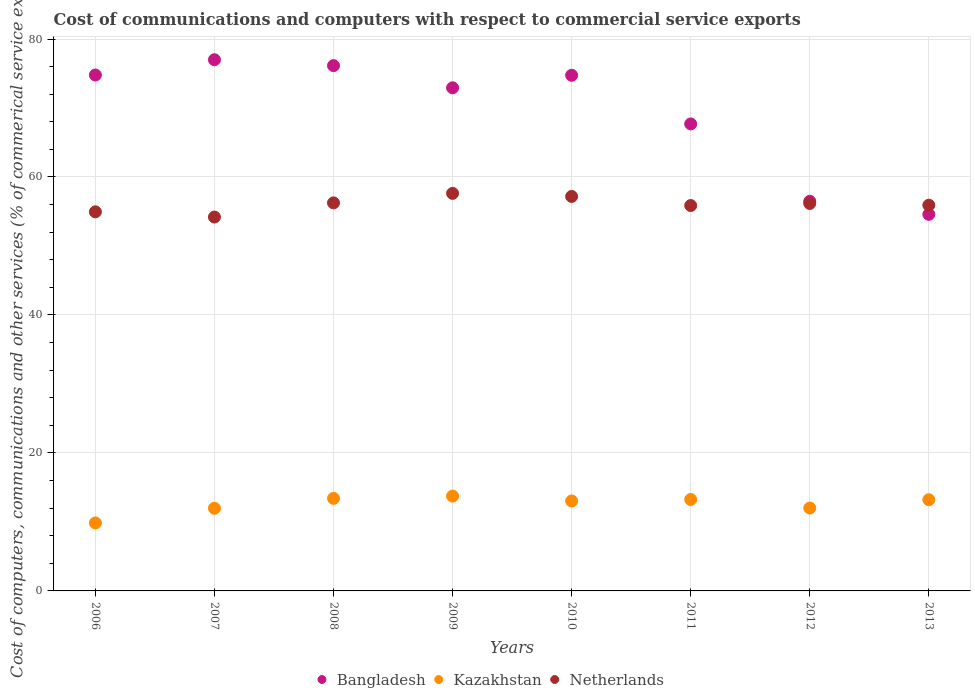Is the number of dotlines equal to the number of legend labels?
Your response must be concise. Yes. What is the cost of communications and computers in Kazakhstan in 2011?
Your answer should be very brief. 13.26. Across all years, what is the maximum cost of communications and computers in Kazakhstan?
Make the answer very short. 13.75. Across all years, what is the minimum cost of communications and computers in Bangladesh?
Offer a terse response. 54.58. In which year was the cost of communications and computers in Kazakhstan minimum?
Your answer should be compact. 2006. What is the total cost of communications and computers in Bangladesh in the graph?
Your answer should be compact. 554.35. What is the difference between the cost of communications and computers in Kazakhstan in 2012 and that in 2013?
Your response must be concise. -1.2. What is the difference between the cost of communications and computers in Netherlands in 2013 and the cost of communications and computers in Bangladesh in 2010?
Give a very brief answer. -18.83. What is the average cost of communications and computers in Bangladesh per year?
Keep it short and to the point. 69.29. In the year 2012, what is the difference between the cost of communications and computers in Bangladesh and cost of communications and computers in Kazakhstan?
Give a very brief answer. 44.46. In how many years, is the cost of communications and computers in Netherlands greater than 16 %?
Your answer should be very brief. 8. What is the ratio of the cost of communications and computers in Bangladesh in 2006 to that in 2007?
Your answer should be very brief. 0.97. Is the difference between the cost of communications and computers in Bangladesh in 2006 and 2007 greater than the difference between the cost of communications and computers in Kazakhstan in 2006 and 2007?
Offer a terse response. No. What is the difference between the highest and the second highest cost of communications and computers in Netherlands?
Ensure brevity in your answer.  0.44. What is the difference between the highest and the lowest cost of communications and computers in Netherlands?
Provide a short and direct response. 3.43. Is the cost of communications and computers in Kazakhstan strictly less than the cost of communications and computers in Bangladesh over the years?
Give a very brief answer. Yes. How many years are there in the graph?
Your answer should be compact. 8. Are the values on the major ticks of Y-axis written in scientific E-notation?
Ensure brevity in your answer.  No. How many legend labels are there?
Make the answer very short. 3. What is the title of the graph?
Your answer should be compact. Cost of communications and computers with respect to commercial service exports. Does "Brazil" appear as one of the legend labels in the graph?
Make the answer very short. No. What is the label or title of the Y-axis?
Your answer should be very brief. Cost of computers, communications and other services (% of commerical service exports). What is the Cost of computers, communications and other services (% of commerical service exports) in Bangladesh in 2006?
Keep it short and to the point. 74.78. What is the Cost of computers, communications and other services (% of commerical service exports) in Kazakhstan in 2006?
Your answer should be compact. 9.85. What is the Cost of computers, communications and other services (% of commerical service exports) in Netherlands in 2006?
Keep it short and to the point. 54.95. What is the Cost of computers, communications and other services (% of commerical service exports) of Bangladesh in 2007?
Provide a short and direct response. 77. What is the Cost of computers, communications and other services (% of commerical service exports) of Kazakhstan in 2007?
Provide a succinct answer. 11.98. What is the Cost of computers, communications and other services (% of commerical service exports) in Netherlands in 2007?
Make the answer very short. 54.19. What is the Cost of computers, communications and other services (% of commerical service exports) in Bangladesh in 2008?
Keep it short and to the point. 76.14. What is the Cost of computers, communications and other services (% of commerical service exports) of Kazakhstan in 2008?
Offer a very short reply. 13.42. What is the Cost of computers, communications and other services (% of commerical service exports) in Netherlands in 2008?
Your answer should be compact. 56.25. What is the Cost of computers, communications and other services (% of commerical service exports) of Bangladesh in 2009?
Give a very brief answer. 72.93. What is the Cost of computers, communications and other services (% of commerical service exports) of Kazakhstan in 2009?
Make the answer very short. 13.75. What is the Cost of computers, communications and other services (% of commerical service exports) in Netherlands in 2009?
Give a very brief answer. 57.63. What is the Cost of computers, communications and other services (% of commerical service exports) of Bangladesh in 2010?
Ensure brevity in your answer.  74.75. What is the Cost of computers, communications and other services (% of commerical service exports) in Kazakhstan in 2010?
Offer a very short reply. 13.04. What is the Cost of computers, communications and other services (% of commerical service exports) of Netherlands in 2010?
Provide a succinct answer. 57.18. What is the Cost of computers, communications and other services (% of commerical service exports) of Bangladesh in 2011?
Your answer should be compact. 67.69. What is the Cost of computers, communications and other services (% of commerical service exports) of Kazakhstan in 2011?
Provide a succinct answer. 13.26. What is the Cost of computers, communications and other services (% of commerical service exports) of Netherlands in 2011?
Your answer should be compact. 55.86. What is the Cost of computers, communications and other services (% of commerical service exports) in Bangladesh in 2012?
Provide a short and direct response. 56.48. What is the Cost of computers, communications and other services (% of commerical service exports) in Kazakhstan in 2012?
Your answer should be very brief. 12.02. What is the Cost of computers, communications and other services (% of commerical service exports) in Netherlands in 2012?
Give a very brief answer. 56.16. What is the Cost of computers, communications and other services (% of commerical service exports) of Bangladesh in 2013?
Your answer should be compact. 54.58. What is the Cost of computers, communications and other services (% of commerical service exports) of Kazakhstan in 2013?
Your response must be concise. 13.22. What is the Cost of computers, communications and other services (% of commerical service exports) in Netherlands in 2013?
Your response must be concise. 55.91. Across all years, what is the maximum Cost of computers, communications and other services (% of commerical service exports) of Bangladesh?
Give a very brief answer. 77. Across all years, what is the maximum Cost of computers, communications and other services (% of commerical service exports) in Kazakhstan?
Ensure brevity in your answer.  13.75. Across all years, what is the maximum Cost of computers, communications and other services (% of commerical service exports) of Netherlands?
Offer a very short reply. 57.63. Across all years, what is the minimum Cost of computers, communications and other services (% of commerical service exports) in Bangladesh?
Provide a short and direct response. 54.58. Across all years, what is the minimum Cost of computers, communications and other services (% of commerical service exports) in Kazakhstan?
Your answer should be compact. 9.85. Across all years, what is the minimum Cost of computers, communications and other services (% of commerical service exports) of Netherlands?
Offer a terse response. 54.19. What is the total Cost of computers, communications and other services (% of commerical service exports) of Bangladesh in the graph?
Offer a terse response. 554.35. What is the total Cost of computers, communications and other services (% of commerical service exports) in Kazakhstan in the graph?
Your response must be concise. 100.53. What is the total Cost of computers, communications and other services (% of commerical service exports) in Netherlands in the graph?
Your response must be concise. 448.14. What is the difference between the Cost of computers, communications and other services (% of commerical service exports) of Bangladesh in 2006 and that in 2007?
Your response must be concise. -2.21. What is the difference between the Cost of computers, communications and other services (% of commerical service exports) in Kazakhstan in 2006 and that in 2007?
Ensure brevity in your answer.  -2.12. What is the difference between the Cost of computers, communications and other services (% of commerical service exports) in Netherlands in 2006 and that in 2007?
Your response must be concise. 0.76. What is the difference between the Cost of computers, communications and other services (% of commerical service exports) in Bangladesh in 2006 and that in 2008?
Make the answer very short. -1.36. What is the difference between the Cost of computers, communications and other services (% of commerical service exports) in Kazakhstan in 2006 and that in 2008?
Offer a very short reply. -3.56. What is the difference between the Cost of computers, communications and other services (% of commerical service exports) in Netherlands in 2006 and that in 2008?
Keep it short and to the point. -1.3. What is the difference between the Cost of computers, communications and other services (% of commerical service exports) of Bangladesh in 2006 and that in 2009?
Ensure brevity in your answer.  1.85. What is the difference between the Cost of computers, communications and other services (% of commerical service exports) of Kazakhstan in 2006 and that in 2009?
Provide a short and direct response. -3.89. What is the difference between the Cost of computers, communications and other services (% of commerical service exports) of Netherlands in 2006 and that in 2009?
Offer a terse response. -2.67. What is the difference between the Cost of computers, communications and other services (% of commerical service exports) of Bangladesh in 2006 and that in 2010?
Your answer should be compact. 0.04. What is the difference between the Cost of computers, communications and other services (% of commerical service exports) of Kazakhstan in 2006 and that in 2010?
Give a very brief answer. -3.19. What is the difference between the Cost of computers, communications and other services (% of commerical service exports) in Netherlands in 2006 and that in 2010?
Give a very brief answer. -2.23. What is the difference between the Cost of computers, communications and other services (% of commerical service exports) in Bangladesh in 2006 and that in 2011?
Give a very brief answer. 7.09. What is the difference between the Cost of computers, communications and other services (% of commerical service exports) of Kazakhstan in 2006 and that in 2011?
Your answer should be compact. -3.4. What is the difference between the Cost of computers, communications and other services (% of commerical service exports) in Netherlands in 2006 and that in 2011?
Offer a terse response. -0.91. What is the difference between the Cost of computers, communications and other services (% of commerical service exports) of Bangladesh in 2006 and that in 2012?
Ensure brevity in your answer.  18.3. What is the difference between the Cost of computers, communications and other services (% of commerical service exports) in Kazakhstan in 2006 and that in 2012?
Your answer should be very brief. -2.16. What is the difference between the Cost of computers, communications and other services (% of commerical service exports) of Netherlands in 2006 and that in 2012?
Ensure brevity in your answer.  -1.21. What is the difference between the Cost of computers, communications and other services (% of commerical service exports) in Bangladesh in 2006 and that in 2013?
Offer a very short reply. 20.2. What is the difference between the Cost of computers, communications and other services (% of commerical service exports) in Kazakhstan in 2006 and that in 2013?
Your answer should be compact. -3.37. What is the difference between the Cost of computers, communications and other services (% of commerical service exports) of Netherlands in 2006 and that in 2013?
Provide a succinct answer. -0.96. What is the difference between the Cost of computers, communications and other services (% of commerical service exports) in Bangladesh in 2007 and that in 2008?
Provide a short and direct response. 0.86. What is the difference between the Cost of computers, communications and other services (% of commerical service exports) of Kazakhstan in 2007 and that in 2008?
Make the answer very short. -1.44. What is the difference between the Cost of computers, communications and other services (% of commerical service exports) of Netherlands in 2007 and that in 2008?
Ensure brevity in your answer.  -2.05. What is the difference between the Cost of computers, communications and other services (% of commerical service exports) of Bangladesh in 2007 and that in 2009?
Keep it short and to the point. 4.07. What is the difference between the Cost of computers, communications and other services (% of commerical service exports) of Kazakhstan in 2007 and that in 2009?
Provide a short and direct response. -1.77. What is the difference between the Cost of computers, communications and other services (% of commerical service exports) of Netherlands in 2007 and that in 2009?
Your response must be concise. -3.43. What is the difference between the Cost of computers, communications and other services (% of commerical service exports) of Bangladesh in 2007 and that in 2010?
Your answer should be very brief. 2.25. What is the difference between the Cost of computers, communications and other services (% of commerical service exports) of Kazakhstan in 2007 and that in 2010?
Offer a very short reply. -1.06. What is the difference between the Cost of computers, communications and other services (% of commerical service exports) in Netherlands in 2007 and that in 2010?
Your response must be concise. -2.99. What is the difference between the Cost of computers, communications and other services (% of commerical service exports) of Bangladesh in 2007 and that in 2011?
Your answer should be compact. 9.3. What is the difference between the Cost of computers, communications and other services (% of commerical service exports) in Kazakhstan in 2007 and that in 2011?
Your answer should be very brief. -1.28. What is the difference between the Cost of computers, communications and other services (% of commerical service exports) of Netherlands in 2007 and that in 2011?
Keep it short and to the point. -1.67. What is the difference between the Cost of computers, communications and other services (% of commerical service exports) of Bangladesh in 2007 and that in 2012?
Your answer should be very brief. 20.52. What is the difference between the Cost of computers, communications and other services (% of commerical service exports) of Kazakhstan in 2007 and that in 2012?
Keep it short and to the point. -0.04. What is the difference between the Cost of computers, communications and other services (% of commerical service exports) in Netherlands in 2007 and that in 2012?
Ensure brevity in your answer.  -1.97. What is the difference between the Cost of computers, communications and other services (% of commerical service exports) in Bangladesh in 2007 and that in 2013?
Provide a succinct answer. 22.41. What is the difference between the Cost of computers, communications and other services (% of commerical service exports) of Kazakhstan in 2007 and that in 2013?
Provide a succinct answer. -1.24. What is the difference between the Cost of computers, communications and other services (% of commerical service exports) of Netherlands in 2007 and that in 2013?
Make the answer very short. -1.72. What is the difference between the Cost of computers, communications and other services (% of commerical service exports) of Bangladesh in 2008 and that in 2009?
Your answer should be very brief. 3.21. What is the difference between the Cost of computers, communications and other services (% of commerical service exports) of Kazakhstan in 2008 and that in 2009?
Your answer should be compact. -0.33. What is the difference between the Cost of computers, communications and other services (% of commerical service exports) of Netherlands in 2008 and that in 2009?
Your answer should be very brief. -1.38. What is the difference between the Cost of computers, communications and other services (% of commerical service exports) in Bangladesh in 2008 and that in 2010?
Give a very brief answer. 1.4. What is the difference between the Cost of computers, communications and other services (% of commerical service exports) of Kazakhstan in 2008 and that in 2010?
Offer a very short reply. 0.38. What is the difference between the Cost of computers, communications and other services (% of commerical service exports) of Netherlands in 2008 and that in 2010?
Your answer should be compact. -0.94. What is the difference between the Cost of computers, communications and other services (% of commerical service exports) in Bangladesh in 2008 and that in 2011?
Your answer should be compact. 8.45. What is the difference between the Cost of computers, communications and other services (% of commerical service exports) in Kazakhstan in 2008 and that in 2011?
Provide a short and direct response. 0.16. What is the difference between the Cost of computers, communications and other services (% of commerical service exports) in Netherlands in 2008 and that in 2011?
Your answer should be very brief. 0.39. What is the difference between the Cost of computers, communications and other services (% of commerical service exports) of Bangladesh in 2008 and that in 2012?
Ensure brevity in your answer.  19.66. What is the difference between the Cost of computers, communications and other services (% of commerical service exports) of Kazakhstan in 2008 and that in 2012?
Keep it short and to the point. 1.4. What is the difference between the Cost of computers, communications and other services (% of commerical service exports) of Netherlands in 2008 and that in 2012?
Keep it short and to the point. 0.08. What is the difference between the Cost of computers, communications and other services (% of commerical service exports) of Bangladesh in 2008 and that in 2013?
Provide a succinct answer. 21.56. What is the difference between the Cost of computers, communications and other services (% of commerical service exports) of Kazakhstan in 2008 and that in 2013?
Provide a succinct answer. 0.2. What is the difference between the Cost of computers, communications and other services (% of commerical service exports) in Netherlands in 2008 and that in 2013?
Your answer should be compact. 0.33. What is the difference between the Cost of computers, communications and other services (% of commerical service exports) in Bangladesh in 2009 and that in 2010?
Keep it short and to the point. -1.82. What is the difference between the Cost of computers, communications and other services (% of commerical service exports) of Kazakhstan in 2009 and that in 2010?
Your answer should be very brief. 0.71. What is the difference between the Cost of computers, communications and other services (% of commerical service exports) in Netherlands in 2009 and that in 2010?
Provide a short and direct response. 0.44. What is the difference between the Cost of computers, communications and other services (% of commerical service exports) in Bangladesh in 2009 and that in 2011?
Offer a terse response. 5.23. What is the difference between the Cost of computers, communications and other services (% of commerical service exports) in Kazakhstan in 2009 and that in 2011?
Offer a terse response. 0.49. What is the difference between the Cost of computers, communications and other services (% of commerical service exports) of Netherlands in 2009 and that in 2011?
Ensure brevity in your answer.  1.76. What is the difference between the Cost of computers, communications and other services (% of commerical service exports) in Bangladesh in 2009 and that in 2012?
Your answer should be compact. 16.45. What is the difference between the Cost of computers, communications and other services (% of commerical service exports) in Kazakhstan in 2009 and that in 2012?
Make the answer very short. 1.73. What is the difference between the Cost of computers, communications and other services (% of commerical service exports) of Netherlands in 2009 and that in 2012?
Ensure brevity in your answer.  1.46. What is the difference between the Cost of computers, communications and other services (% of commerical service exports) of Bangladesh in 2009 and that in 2013?
Ensure brevity in your answer.  18.34. What is the difference between the Cost of computers, communications and other services (% of commerical service exports) in Kazakhstan in 2009 and that in 2013?
Give a very brief answer. 0.53. What is the difference between the Cost of computers, communications and other services (% of commerical service exports) of Netherlands in 2009 and that in 2013?
Offer a very short reply. 1.71. What is the difference between the Cost of computers, communications and other services (% of commerical service exports) of Bangladesh in 2010 and that in 2011?
Keep it short and to the point. 7.05. What is the difference between the Cost of computers, communications and other services (% of commerical service exports) in Kazakhstan in 2010 and that in 2011?
Offer a terse response. -0.22. What is the difference between the Cost of computers, communications and other services (% of commerical service exports) of Netherlands in 2010 and that in 2011?
Offer a terse response. 1.32. What is the difference between the Cost of computers, communications and other services (% of commerical service exports) in Bangladesh in 2010 and that in 2012?
Provide a short and direct response. 18.27. What is the difference between the Cost of computers, communications and other services (% of commerical service exports) in Kazakhstan in 2010 and that in 2012?
Your response must be concise. 1.03. What is the difference between the Cost of computers, communications and other services (% of commerical service exports) of Netherlands in 2010 and that in 2012?
Your response must be concise. 1.02. What is the difference between the Cost of computers, communications and other services (% of commerical service exports) of Bangladesh in 2010 and that in 2013?
Keep it short and to the point. 20.16. What is the difference between the Cost of computers, communications and other services (% of commerical service exports) in Kazakhstan in 2010 and that in 2013?
Keep it short and to the point. -0.18. What is the difference between the Cost of computers, communications and other services (% of commerical service exports) of Netherlands in 2010 and that in 2013?
Give a very brief answer. 1.27. What is the difference between the Cost of computers, communications and other services (% of commerical service exports) of Bangladesh in 2011 and that in 2012?
Ensure brevity in your answer.  11.21. What is the difference between the Cost of computers, communications and other services (% of commerical service exports) of Kazakhstan in 2011 and that in 2012?
Make the answer very short. 1.24. What is the difference between the Cost of computers, communications and other services (% of commerical service exports) of Netherlands in 2011 and that in 2012?
Make the answer very short. -0.3. What is the difference between the Cost of computers, communications and other services (% of commerical service exports) in Bangladesh in 2011 and that in 2013?
Your answer should be very brief. 13.11. What is the difference between the Cost of computers, communications and other services (% of commerical service exports) in Kazakhstan in 2011 and that in 2013?
Provide a short and direct response. 0.04. What is the difference between the Cost of computers, communications and other services (% of commerical service exports) in Netherlands in 2011 and that in 2013?
Ensure brevity in your answer.  -0.05. What is the difference between the Cost of computers, communications and other services (% of commerical service exports) in Bangladesh in 2012 and that in 2013?
Make the answer very short. 1.9. What is the difference between the Cost of computers, communications and other services (% of commerical service exports) in Kazakhstan in 2012 and that in 2013?
Keep it short and to the point. -1.2. What is the difference between the Cost of computers, communications and other services (% of commerical service exports) of Netherlands in 2012 and that in 2013?
Make the answer very short. 0.25. What is the difference between the Cost of computers, communications and other services (% of commerical service exports) of Bangladesh in 2006 and the Cost of computers, communications and other services (% of commerical service exports) of Kazakhstan in 2007?
Your answer should be very brief. 62.8. What is the difference between the Cost of computers, communications and other services (% of commerical service exports) in Bangladesh in 2006 and the Cost of computers, communications and other services (% of commerical service exports) in Netherlands in 2007?
Provide a short and direct response. 20.59. What is the difference between the Cost of computers, communications and other services (% of commerical service exports) in Kazakhstan in 2006 and the Cost of computers, communications and other services (% of commerical service exports) in Netherlands in 2007?
Ensure brevity in your answer.  -44.34. What is the difference between the Cost of computers, communications and other services (% of commerical service exports) in Bangladesh in 2006 and the Cost of computers, communications and other services (% of commerical service exports) in Kazakhstan in 2008?
Your answer should be very brief. 61.37. What is the difference between the Cost of computers, communications and other services (% of commerical service exports) in Bangladesh in 2006 and the Cost of computers, communications and other services (% of commerical service exports) in Netherlands in 2008?
Your answer should be compact. 18.53. What is the difference between the Cost of computers, communications and other services (% of commerical service exports) in Kazakhstan in 2006 and the Cost of computers, communications and other services (% of commerical service exports) in Netherlands in 2008?
Your answer should be very brief. -46.39. What is the difference between the Cost of computers, communications and other services (% of commerical service exports) of Bangladesh in 2006 and the Cost of computers, communications and other services (% of commerical service exports) of Kazakhstan in 2009?
Your answer should be compact. 61.03. What is the difference between the Cost of computers, communications and other services (% of commerical service exports) in Bangladesh in 2006 and the Cost of computers, communications and other services (% of commerical service exports) in Netherlands in 2009?
Your response must be concise. 17.16. What is the difference between the Cost of computers, communications and other services (% of commerical service exports) in Kazakhstan in 2006 and the Cost of computers, communications and other services (% of commerical service exports) in Netherlands in 2009?
Your answer should be very brief. -47.77. What is the difference between the Cost of computers, communications and other services (% of commerical service exports) in Bangladesh in 2006 and the Cost of computers, communications and other services (% of commerical service exports) in Kazakhstan in 2010?
Provide a short and direct response. 61.74. What is the difference between the Cost of computers, communications and other services (% of commerical service exports) of Bangladesh in 2006 and the Cost of computers, communications and other services (% of commerical service exports) of Netherlands in 2010?
Keep it short and to the point. 17.6. What is the difference between the Cost of computers, communications and other services (% of commerical service exports) in Kazakhstan in 2006 and the Cost of computers, communications and other services (% of commerical service exports) in Netherlands in 2010?
Provide a succinct answer. -47.33. What is the difference between the Cost of computers, communications and other services (% of commerical service exports) in Bangladesh in 2006 and the Cost of computers, communications and other services (% of commerical service exports) in Kazakhstan in 2011?
Your response must be concise. 61.53. What is the difference between the Cost of computers, communications and other services (% of commerical service exports) in Bangladesh in 2006 and the Cost of computers, communications and other services (% of commerical service exports) in Netherlands in 2011?
Offer a very short reply. 18.92. What is the difference between the Cost of computers, communications and other services (% of commerical service exports) in Kazakhstan in 2006 and the Cost of computers, communications and other services (% of commerical service exports) in Netherlands in 2011?
Ensure brevity in your answer.  -46.01. What is the difference between the Cost of computers, communications and other services (% of commerical service exports) of Bangladesh in 2006 and the Cost of computers, communications and other services (% of commerical service exports) of Kazakhstan in 2012?
Provide a succinct answer. 62.77. What is the difference between the Cost of computers, communications and other services (% of commerical service exports) in Bangladesh in 2006 and the Cost of computers, communications and other services (% of commerical service exports) in Netherlands in 2012?
Provide a short and direct response. 18.62. What is the difference between the Cost of computers, communications and other services (% of commerical service exports) in Kazakhstan in 2006 and the Cost of computers, communications and other services (% of commerical service exports) in Netherlands in 2012?
Ensure brevity in your answer.  -46.31. What is the difference between the Cost of computers, communications and other services (% of commerical service exports) in Bangladesh in 2006 and the Cost of computers, communications and other services (% of commerical service exports) in Kazakhstan in 2013?
Offer a very short reply. 61.56. What is the difference between the Cost of computers, communications and other services (% of commerical service exports) in Bangladesh in 2006 and the Cost of computers, communications and other services (% of commerical service exports) in Netherlands in 2013?
Your answer should be compact. 18.87. What is the difference between the Cost of computers, communications and other services (% of commerical service exports) in Kazakhstan in 2006 and the Cost of computers, communications and other services (% of commerical service exports) in Netherlands in 2013?
Your answer should be compact. -46.06. What is the difference between the Cost of computers, communications and other services (% of commerical service exports) in Bangladesh in 2007 and the Cost of computers, communications and other services (% of commerical service exports) in Kazakhstan in 2008?
Ensure brevity in your answer.  63.58. What is the difference between the Cost of computers, communications and other services (% of commerical service exports) in Bangladesh in 2007 and the Cost of computers, communications and other services (% of commerical service exports) in Netherlands in 2008?
Provide a short and direct response. 20.75. What is the difference between the Cost of computers, communications and other services (% of commerical service exports) in Kazakhstan in 2007 and the Cost of computers, communications and other services (% of commerical service exports) in Netherlands in 2008?
Offer a terse response. -44.27. What is the difference between the Cost of computers, communications and other services (% of commerical service exports) of Bangladesh in 2007 and the Cost of computers, communications and other services (% of commerical service exports) of Kazakhstan in 2009?
Provide a succinct answer. 63.25. What is the difference between the Cost of computers, communications and other services (% of commerical service exports) in Bangladesh in 2007 and the Cost of computers, communications and other services (% of commerical service exports) in Netherlands in 2009?
Make the answer very short. 19.37. What is the difference between the Cost of computers, communications and other services (% of commerical service exports) in Kazakhstan in 2007 and the Cost of computers, communications and other services (% of commerical service exports) in Netherlands in 2009?
Ensure brevity in your answer.  -45.65. What is the difference between the Cost of computers, communications and other services (% of commerical service exports) of Bangladesh in 2007 and the Cost of computers, communications and other services (% of commerical service exports) of Kazakhstan in 2010?
Your response must be concise. 63.96. What is the difference between the Cost of computers, communications and other services (% of commerical service exports) of Bangladesh in 2007 and the Cost of computers, communications and other services (% of commerical service exports) of Netherlands in 2010?
Provide a short and direct response. 19.81. What is the difference between the Cost of computers, communications and other services (% of commerical service exports) in Kazakhstan in 2007 and the Cost of computers, communications and other services (% of commerical service exports) in Netherlands in 2010?
Ensure brevity in your answer.  -45.2. What is the difference between the Cost of computers, communications and other services (% of commerical service exports) in Bangladesh in 2007 and the Cost of computers, communications and other services (% of commerical service exports) in Kazakhstan in 2011?
Give a very brief answer. 63.74. What is the difference between the Cost of computers, communications and other services (% of commerical service exports) of Bangladesh in 2007 and the Cost of computers, communications and other services (% of commerical service exports) of Netherlands in 2011?
Provide a short and direct response. 21.13. What is the difference between the Cost of computers, communications and other services (% of commerical service exports) of Kazakhstan in 2007 and the Cost of computers, communications and other services (% of commerical service exports) of Netherlands in 2011?
Offer a very short reply. -43.88. What is the difference between the Cost of computers, communications and other services (% of commerical service exports) in Bangladesh in 2007 and the Cost of computers, communications and other services (% of commerical service exports) in Kazakhstan in 2012?
Ensure brevity in your answer.  64.98. What is the difference between the Cost of computers, communications and other services (% of commerical service exports) of Bangladesh in 2007 and the Cost of computers, communications and other services (% of commerical service exports) of Netherlands in 2012?
Make the answer very short. 20.83. What is the difference between the Cost of computers, communications and other services (% of commerical service exports) in Kazakhstan in 2007 and the Cost of computers, communications and other services (% of commerical service exports) in Netherlands in 2012?
Make the answer very short. -44.19. What is the difference between the Cost of computers, communications and other services (% of commerical service exports) of Bangladesh in 2007 and the Cost of computers, communications and other services (% of commerical service exports) of Kazakhstan in 2013?
Offer a very short reply. 63.78. What is the difference between the Cost of computers, communications and other services (% of commerical service exports) of Bangladesh in 2007 and the Cost of computers, communications and other services (% of commerical service exports) of Netherlands in 2013?
Offer a terse response. 21.08. What is the difference between the Cost of computers, communications and other services (% of commerical service exports) of Kazakhstan in 2007 and the Cost of computers, communications and other services (% of commerical service exports) of Netherlands in 2013?
Ensure brevity in your answer.  -43.93. What is the difference between the Cost of computers, communications and other services (% of commerical service exports) in Bangladesh in 2008 and the Cost of computers, communications and other services (% of commerical service exports) in Kazakhstan in 2009?
Ensure brevity in your answer.  62.39. What is the difference between the Cost of computers, communications and other services (% of commerical service exports) of Bangladesh in 2008 and the Cost of computers, communications and other services (% of commerical service exports) of Netherlands in 2009?
Provide a short and direct response. 18.52. What is the difference between the Cost of computers, communications and other services (% of commerical service exports) of Kazakhstan in 2008 and the Cost of computers, communications and other services (% of commerical service exports) of Netherlands in 2009?
Provide a short and direct response. -44.21. What is the difference between the Cost of computers, communications and other services (% of commerical service exports) of Bangladesh in 2008 and the Cost of computers, communications and other services (% of commerical service exports) of Kazakhstan in 2010?
Offer a terse response. 63.1. What is the difference between the Cost of computers, communications and other services (% of commerical service exports) in Bangladesh in 2008 and the Cost of computers, communications and other services (% of commerical service exports) in Netherlands in 2010?
Make the answer very short. 18.96. What is the difference between the Cost of computers, communications and other services (% of commerical service exports) of Kazakhstan in 2008 and the Cost of computers, communications and other services (% of commerical service exports) of Netherlands in 2010?
Offer a very short reply. -43.77. What is the difference between the Cost of computers, communications and other services (% of commerical service exports) of Bangladesh in 2008 and the Cost of computers, communications and other services (% of commerical service exports) of Kazakhstan in 2011?
Offer a terse response. 62.88. What is the difference between the Cost of computers, communications and other services (% of commerical service exports) in Bangladesh in 2008 and the Cost of computers, communications and other services (% of commerical service exports) in Netherlands in 2011?
Ensure brevity in your answer.  20.28. What is the difference between the Cost of computers, communications and other services (% of commerical service exports) in Kazakhstan in 2008 and the Cost of computers, communications and other services (% of commerical service exports) in Netherlands in 2011?
Offer a very short reply. -42.45. What is the difference between the Cost of computers, communications and other services (% of commerical service exports) of Bangladesh in 2008 and the Cost of computers, communications and other services (% of commerical service exports) of Kazakhstan in 2012?
Your response must be concise. 64.13. What is the difference between the Cost of computers, communications and other services (% of commerical service exports) of Bangladesh in 2008 and the Cost of computers, communications and other services (% of commerical service exports) of Netherlands in 2012?
Ensure brevity in your answer.  19.98. What is the difference between the Cost of computers, communications and other services (% of commerical service exports) in Kazakhstan in 2008 and the Cost of computers, communications and other services (% of commerical service exports) in Netherlands in 2012?
Your answer should be compact. -42.75. What is the difference between the Cost of computers, communications and other services (% of commerical service exports) in Bangladesh in 2008 and the Cost of computers, communications and other services (% of commerical service exports) in Kazakhstan in 2013?
Your answer should be compact. 62.92. What is the difference between the Cost of computers, communications and other services (% of commerical service exports) of Bangladesh in 2008 and the Cost of computers, communications and other services (% of commerical service exports) of Netherlands in 2013?
Your response must be concise. 20.23. What is the difference between the Cost of computers, communications and other services (% of commerical service exports) of Kazakhstan in 2008 and the Cost of computers, communications and other services (% of commerical service exports) of Netherlands in 2013?
Provide a succinct answer. -42.5. What is the difference between the Cost of computers, communications and other services (% of commerical service exports) in Bangladesh in 2009 and the Cost of computers, communications and other services (% of commerical service exports) in Kazakhstan in 2010?
Make the answer very short. 59.89. What is the difference between the Cost of computers, communications and other services (% of commerical service exports) in Bangladesh in 2009 and the Cost of computers, communications and other services (% of commerical service exports) in Netherlands in 2010?
Give a very brief answer. 15.74. What is the difference between the Cost of computers, communications and other services (% of commerical service exports) of Kazakhstan in 2009 and the Cost of computers, communications and other services (% of commerical service exports) of Netherlands in 2010?
Make the answer very short. -43.43. What is the difference between the Cost of computers, communications and other services (% of commerical service exports) of Bangladesh in 2009 and the Cost of computers, communications and other services (% of commerical service exports) of Kazakhstan in 2011?
Offer a terse response. 59.67. What is the difference between the Cost of computers, communications and other services (% of commerical service exports) of Bangladesh in 2009 and the Cost of computers, communications and other services (% of commerical service exports) of Netherlands in 2011?
Keep it short and to the point. 17.06. What is the difference between the Cost of computers, communications and other services (% of commerical service exports) in Kazakhstan in 2009 and the Cost of computers, communications and other services (% of commerical service exports) in Netherlands in 2011?
Ensure brevity in your answer.  -42.11. What is the difference between the Cost of computers, communications and other services (% of commerical service exports) of Bangladesh in 2009 and the Cost of computers, communications and other services (% of commerical service exports) of Kazakhstan in 2012?
Keep it short and to the point. 60.91. What is the difference between the Cost of computers, communications and other services (% of commerical service exports) of Bangladesh in 2009 and the Cost of computers, communications and other services (% of commerical service exports) of Netherlands in 2012?
Offer a terse response. 16.76. What is the difference between the Cost of computers, communications and other services (% of commerical service exports) of Kazakhstan in 2009 and the Cost of computers, communications and other services (% of commerical service exports) of Netherlands in 2012?
Offer a very short reply. -42.42. What is the difference between the Cost of computers, communications and other services (% of commerical service exports) in Bangladesh in 2009 and the Cost of computers, communications and other services (% of commerical service exports) in Kazakhstan in 2013?
Your answer should be very brief. 59.71. What is the difference between the Cost of computers, communications and other services (% of commerical service exports) in Bangladesh in 2009 and the Cost of computers, communications and other services (% of commerical service exports) in Netherlands in 2013?
Provide a succinct answer. 17.01. What is the difference between the Cost of computers, communications and other services (% of commerical service exports) of Kazakhstan in 2009 and the Cost of computers, communications and other services (% of commerical service exports) of Netherlands in 2013?
Provide a succinct answer. -42.16. What is the difference between the Cost of computers, communications and other services (% of commerical service exports) in Bangladesh in 2010 and the Cost of computers, communications and other services (% of commerical service exports) in Kazakhstan in 2011?
Provide a succinct answer. 61.49. What is the difference between the Cost of computers, communications and other services (% of commerical service exports) of Bangladesh in 2010 and the Cost of computers, communications and other services (% of commerical service exports) of Netherlands in 2011?
Your answer should be compact. 18.88. What is the difference between the Cost of computers, communications and other services (% of commerical service exports) of Kazakhstan in 2010 and the Cost of computers, communications and other services (% of commerical service exports) of Netherlands in 2011?
Ensure brevity in your answer.  -42.82. What is the difference between the Cost of computers, communications and other services (% of commerical service exports) in Bangladesh in 2010 and the Cost of computers, communications and other services (% of commerical service exports) in Kazakhstan in 2012?
Your answer should be very brief. 62.73. What is the difference between the Cost of computers, communications and other services (% of commerical service exports) of Bangladesh in 2010 and the Cost of computers, communications and other services (% of commerical service exports) of Netherlands in 2012?
Your response must be concise. 18.58. What is the difference between the Cost of computers, communications and other services (% of commerical service exports) in Kazakhstan in 2010 and the Cost of computers, communications and other services (% of commerical service exports) in Netherlands in 2012?
Your answer should be very brief. -43.12. What is the difference between the Cost of computers, communications and other services (% of commerical service exports) of Bangladesh in 2010 and the Cost of computers, communications and other services (% of commerical service exports) of Kazakhstan in 2013?
Offer a terse response. 61.53. What is the difference between the Cost of computers, communications and other services (% of commerical service exports) of Bangladesh in 2010 and the Cost of computers, communications and other services (% of commerical service exports) of Netherlands in 2013?
Keep it short and to the point. 18.83. What is the difference between the Cost of computers, communications and other services (% of commerical service exports) in Kazakhstan in 2010 and the Cost of computers, communications and other services (% of commerical service exports) in Netherlands in 2013?
Make the answer very short. -42.87. What is the difference between the Cost of computers, communications and other services (% of commerical service exports) in Bangladesh in 2011 and the Cost of computers, communications and other services (% of commerical service exports) in Kazakhstan in 2012?
Your answer should be compact. 55.68. What is the difference between the Cost of computers, communications and other services (% of commerical service exports) of Bangladesh in 2011 and the Cost of computers, communications and other services (% of commerical service exports) of Netherlands in 2012?
Make the answer very short. 11.53. What is the difference between the Cost of computers, communications and other services (% of commerical service exports) in Kazakhstan in 2011 and the Cost of computers, communications and other services (% of commerical service exports) in Netherlands in 2012?
Provide a succinct answer. -42.91. What is the difference between the Cost of computers, communications and other services (% of commerical service exports) in Bangladesh in 2011 and the Cost of computers, communications and other services (% of commerical service exports) in Kazakhstan in 2013?
Make the answer very short. 54.47. What is the difference between the Cost of computers, communications and other services (% of commerical service exports) of Bangladesh in 2011 and the Cost of computers, communications and other services (% of commerical service exports) of Netherlands in 2013?
Make the answer very short. 11.78. What is the difference between the Cost of computers, communications and other services (% of commerical service exports) in Kazakhstan in 2011 and the Cost of computers, communications and other services (% of commerical service exports) in Netherlands in 2013?
Ensure brevity in your answer.  -42.66. What is the difference between the Cost of computers, communications and other services (% of commerical service exports) in Bangladesh in 2012 and the Cost of computers, communications and other services (% of commerical service exports) in Kazakhstan in 2013?
Make the answer very short. 43.26. What is the difference between the Cost of computers, communications and other services (% of commerical service exports) of Bangladesh in 2012 and the Cost of computers, communications and other services (% of commerical service exports) of Netherlands in 2013?
Make the answer very short. 0.56. What is the difference between the Cost of computers, communications and other services (% of commerical service exports) of Kazakhstan in 2012 and the Cost of computers, communications and other services (% of commerical service exports) of Netherlands in 2013?
Keep it short and to the point. -43.9. What is the average Cost of computers, communications and other services (% of commerical service exports) in Bangladesh per year?
Make the answer very short. 69.29. What is the average Cost of computers, communications and other services (% of commerical service exports) of Kazakhstan per year?
Give a very brief answer. 12.57. What is the average Cost of computers, communications and other services (% of commerical service exports) of Netherlands per year?
Make the answer very short. 56.02. In the year 2006, what is the difference between the Cost of computers, communications and other services (% of commerical service exports) of Bangladesh and Cost of computers, communications and other services (% of commerical service exports) of Kazakhstan?
Give a very brief answer. 64.93. In the year 2006, what is the difference between the Cost of computers, communications and other services (% of commerical service exports) of Bangladesh and Cost of computers, communications and other services (% of commerical service exports) of Netherlands?
Keep it short and to the point. 19.83. In the year 2006, what is the difference between the Cost of computers, communications and other services (% of commerical service exports) of Kazakhstan and Cost of computers, communications and other services (% of commerical service exports) of Netherlands?
Provide a succinct answer. -45.1. In the year 2007, what is the difference between the Cost of computers, communications and other services (% of commerical service exports) of Bangladesh and Cost of computers, communications and other services (% of commerical service exports) of Kazakhstan?
Keep it short and to the point. 65.02. In the year 2007, what is the difference between the Cost of computers, communications and other services (% of commerical service exports) of Bangladesh and Cost of computers, communications and other services (% of commerical service exports) of Netherlands?
Provide a succinct answer. 22.8. In the year 2007, what is the difference between the Cost of computers, communications and other services (% of commerical service exports) in Kazakhstan and Cost of computers, communications and other services (% of commerical service exports) in Netherlands?
Offer a very short reply. -42.21. In the year 2008, what is the difference between the Cost of computers, communications and other services (% of commerical service exports) in Bangladesh and Cost of computers, communications and other services (% of commerical service exports) in Kazakhstan?
Ensure brevity in your answer.  62.73. In the year 2008, what is the difference between the Cost of computers, communications and other services (% of commerical service exports) of Bangladesh and Cost of computers, communications and other services (% of commerical service exports) of Netherlands?
Ensure brevity in your answer.  19.89. In the year 2008, what is the difference between the Cost of computers, communications and other services (% of commerical service exports) of Kazakhstan and Cost of computers, communications and other services (% of commerical service exports) of Netherlands?
Your response must be concise. -42.83. In the year 2009, what is the difference between the Cost of computers, communications and other services (% of commerical service exports) in Bangladesh and Cost of computers, communications and other services (% of commerical service exports) in Kazakhstan?
Your answer should be compact. 59.18. In the year 2009, what is the difference between the Cost of computers, communications and other services (% of commerical service exports) of Bangladesh and Cost of computers, communications and other services (% of commerical service exports) of Netherlands?
Provide a short and direct response. 15.3. In the year 2009, what is the difference between the Cost of computers, communications and other services (% of commerical service exports) in Kazakhstan and Cost of computers, communications and other services (% of commerical service exports) in Netherlands?
Your response must be concise. -43.88. In the year 2010, what is the difference between the Cost of computers, communications and other services (% of commerical service exports) of Bangladesh and Cost of computers, communications and other services (% of commerical service exports) of Kazakhstan?
Keep it short and to the point. 61.7. In the year 2010, what is the difference between the Cost of computers, communications and other services (% of commerical service exports) in Bangladesh and Cost of computers, communications and other services (% of commerical service exports) in Netherlands?
Provide a succinct answer. 17.56. In the year 2010, what is the difference between the Cost of computers, communications and other services (% of commerical service exports) of Kazakhstan and Cost of computers, communications and other services (% of commerical service exports) of Netherlands?
Keep it short and to the point. -44.14. In the year 2011, what is the difference between the Cost of computers, communications and other services (% of commerical service exports) of Bangladesh and Cost of computers, communications and other services (% of commerical service exports) of Kazakhstan?
Provide a short and direct response. 54.44. In the year 2011, what is the difference between the Cost of computers, communications and other services (% of commerical service exports) of Bangladesh and Cost of computers, communications and other services (% of commerical service exports) of Netherlands?
Your answer should be compact. 11.83. In the year 2011, what is the difference between the Cost of computers, communications and other services (% of commerical service exports) of Kazakhstan and Cost of computers, communications and other services (% of commerical service exports) of Netherlands?
Your answer should be compact. -42.61. In the year 2012, what is the difference between the Cost of computers, communications and other services (% of commerical service exports) of Bangladesh and Cost of computers, communications and other services (% of commerical service exports) of Kazakhstan?
Provide a short and direct response. 44.46. In the year 2012, what is the difference between the Cost of computers, communications and other services (% of commerical service exports) in Bangladesh and Cost of computers, communications and other services (% of commerical service exports) in Netherlands?
Ensure brevity in your answer.  0.31. In the year 2012, what is the difference between the Cost of computers, communications and other services (% of commerical service exports) in Kazakhstan and Cost of computers, communications and other services (% of commerical service exports) in Netherlands?
Make the answer very short. -44.15. In the year 2013, what is the difference between the Cost of computers, communications and other services (% of commerical service exports) in Bangladesh and Cost of computers, communications and other services (% of commerical service exports) in Kazakhstan?
Make the answer very short. 41.36. In the year 2013, what is the difference between the Cost of computers, communications and other services (% of commerical service exports) in Bangladesh and Cost of computers, communications and other services (% of commerical service exports) in Netherlands?
Offer a very short reply. -1.33. In the year 2013, what is the difference between the Cost of computers, communications and other services (% of commerical service exports) of Kazakhstan and Cost of computers, communications and other services (% of commerical service exports) of Netherlands?
Offer a very short reply. -42.69. What is the ratio of the Cost of computers, communications and other services (% of commerical service exports) in Bangladesh in 2006 to that in 2007?
Offer a very short reply. 0.97. What is the ratio of the Cost of computers, communications and other services (% of commerical service exports) in Kazakhstan in 2006 to that in 2007?
Make the answer very short. 0.82. What is the ratio of the Cost of computers, communications and other services (% of commerical service exports) of Bangladesh in 2006 to that in 2008?
Ensure brevity in your answer.  0.98. What is the ratio of the Cost of computers, communications and other services (% of commerical service exports) of Kazakhstan in 2006 to that in 2008?
Keep it short and to the point. 0.73. What is the ratio of the Cost of computers, communications and other services (% of commerical service exports) in Bangladesh in 2006 to that in 2009?
Your response must be concise. 1.03. What is the ratio of the Cost of computers, communications and other services (% of commerical service exports) in Kazakhstan in 2006 to that in 2009?
Your response must be concise. 0.72. What is the ratio of the Cost of computers, communications and other services (% of commerical service exports) of Netherlands in 2006 to that in 2009?
Keep it short and to the point. 0.95. What is the ratio of the Cost of computers, communications and other services (% of commerical service exports) of Kazakhstan in 2006 to that in 2010?
Your answer should be compact. 0.76. What is the ratio of the Cost of computers, communications and other services (% of commerical service exports) of Bangladesh in 2006 to that in 2011?
Keep it short and to the point. 1.1. What is the ratio of the Cost of computers, communications and other services (% of commerical service exports) in Kazakhstan in 2006 to that in 2011?
Offer a terse response. 0.74. What is the ratio of the Cost of computers, communications and other services (% of commerical service exports) of Netherlands in 2006 to that in 2011?
Ensure brevity in your answer.  0.98. What is the ratio of the Cost of computers, communications and other services (% of commerical service exports) in Bangladesh in 2006 to that in 2012?
Give a very brief answer. 1.32. What is the ratio of the Cost of computers, communications and other services (% of commerical service exports) in Kazakhstan in 2006 to that in 2012?
Provide a succinct answer. 0.82. What is the ratio of the Cost of computers, communications and other services (% of commerical service exports) in Netherlands in 2006 to that in 2012?
Make the answer very short. 0.98. What is the ratio of the Cost of computers, communications and other services (% of commerical service exports) of Bangladesh in 2006 to that in 2013?
Offer a very short reply. 1.37. What is the ratio of the Cost of computers, communications and other services (% of commerical service exports) in Kazakhstan in 2006 to that in 2013?
Offer a very short reply. 0.75. What is the ratio of the Cost of computers, communications and other services (% of commerical service exports) of Netherlands in 2006 to that in 2013?
Keep it short and to the point. 0.98. What is the ratio of the Cost of computers, communications and other services (% of commerical service exports) in Bangladesh in 2007 to that in 2008?
Offer a very short reply. 1.01. What is the ratio of the Cost of computers, communications and other services (% of commerical service exports) of Kazakhstan in 2007 to that in 2008?
Ensure brevity in your answer.  0.89. What is the ratio of the Cost of computers, communications and other services (% of commerical service exports) in Netherlands in 2007 to that in 2008?
Make the answer very short. 0.96. What is the ratio of the Cost of computers, communications and other services (% of commerical service exports) of Bangladesh in 2007 to that in 2009?
Make the answer very short. 1.06. What is the ratio of the Cost of computers, communications and other services (% of commerical service exports) of Kazakhstan in 2007 to that in 2009?
Offer a terse response. 0.87. What is the ratio of the Cost of computers, communications and other services (% of commerical service exports) of Netherlands in 2007 to that in 2009?
Keep it short and to the point. 0.94. What is the ratio of the Cost of computers, communications and other services (% of commerical service exports) in Bangladesh in 2007 to that in 2010?
Give a very brief answer. 1.03. What is the ratio of the Cost of computers, communications and other services (% of commerical service exports) in Kazakhstan in 2007 to that in 2010?
Offer a terse response. 0.92. What is the ratio of the Cost of computers, communications and other services (% of commerical service exports) in Netherlands in 2007 to that in 2010?
Provide a succinct answer. 0.95. What is the ratio of the Cost of computers, communications and other services (% of commerical service exports) of Bangladesh in 2007 to that in 2011?
Your answer should be very brief. 1.14. What is the ratio of the Cost of computers, communications and other services (% of commerical service exports) of Kazakhstan in 2007 to that in 2011?
Your answer should be compact. 0.9. What is the ratio of the Cost of computers, communications and other services (% of commerical service exports) in Netherlands in 2007 to that in 2011?
Give a very brief answer. 0.97. What is the ratio of the Cost of computers, communications and other services (% of commerical service exports) in Bangladesh in 2007 to that in 2012?
Make the answer very short. 1.36. What is the ratio of the Cost of computers, communications and other services (% of commerical service exports) in Kazakhstan in 2007 to that in 2012?
Offer a very short reply. 1. What is the ratio of the Cost of computers, communications and other services (% of commerical service exports) of Netherlands in 2007 to that in 2012?
Offer a very short reply. 0.96. What is the ratio of the Cost of computers, communications and other services (% of commerical service exports) in Bangladesh in 2007 to that in 2013?
Ensure brevity in your answer.  1.41. What is the ratio of the Cost of computers, communications and other services (% of commerical service exports) in Kazakhstan in 2007 to that in 2013?
Give a very brief answer. 0.91. What is the ratio of the Cost of computers, communications and other services (% of commerical service exports) in Netherlands in 2007 to that in 2013?
Your answer should be very brief. 0.97. What is the ratio of the Cost of computers, communications and other services (% of commerical service exports) in Bangladesh in 2008 to that in 2009?
Ensure brevity in your answer.  1.04. What is the ratio of the Cost of computers, communications and other services (% of commerical service exports) of Kazakhstan in 2008 to that in 2009?
Your answer should be very brief. 0.98. What is the ratio of the Cost of computers, communications and other services (% of commerical service exports) of Netherlands in 2008 to that in 2009?
Your answer should be very brief. 0.98. What is the ratio of the Cost of computers, communications and other services (% of commerical service exports) of Bangladesh in 2008 to that in 2010?
Provide a short and direct response. 1.02. What is the ratio of the Cost of computers, communications and other services (% of commerical service exports) of Kazakhstan in 2008 to that in 2010?
Keep it short and to the point. 1.03. What is the ratio of the Cost of computers, communications and other services (% of commerical service exports) in Netherlands in 2008 to that in 2010?
Your answer should be compact. 0.98. What is the ratio of the Cost of computers, communications and other services (% of commerical service exports) in Bangladesh in 2008 to that in 2011?
Keep it short and to the point. 1.12. What is the ratio of the Cost of computers, communications and other services (% of commerical service exports) in Kazakhstan in 2008 to that in 2011?
Provide a short and direct response. 1.01. What is the ratio of the Cost of computers, communications and other services (% of commerical service exports) in Netherlands in 2008 to that in 2011?
Offer a terse response. 1.01. What is the ratio of the Cost of computers, communications and other services (% of commerical service exports) of Bangladesh in 2008 to that in 2012?
Ensure brevity in your answer.  1.35. What is the ratio of the Cost of computers, communications and other services (% of commerical service exports) of Kazakhstan in 2008 to that in 2012?
Offer a terse response. 1.12. What is the ratio of the Cost of computers, communications and other services (% of commerical service exports) in Netherlands in 2008 to that in 2012?
Your response must be concise. 1. What is the ratio of the Cost of computers, communications and other services (% of commerical service exports) in Bangladesh in 2008 to that in 2013?
Offer a very short reply. 1.4. What is the ratio of the Cost of computers, communications and other services (% of commerical service exports) in Kazakhstan in 2008 to that in 2013?
Keep it short and to the point. 1.01. What is the ratio of the Cost of computers, communications and other services (% of commerical service exports) of Bangladesh in 2009 to that in 2010?
Ensure brevity in your answer.  0.98. What is the ratio of the Cost of computers, communications and other services (% of commerical service exports) of Kazakhstan in 2009 to that in 2010?
Your answer should be very brief. 1.05. What is the ratio of the Cost of computers, communications and other services (% of commerical service exports) of Bangladesh in 2009 to that in 2011?
Offer a very short reply. 1.08. What is the ratio of the Cost of computers, communications and other services (% of commerical service exports) of Kazakhstan in 2009 to that in 2011?
Ensure brevity in your answer.  1.04. What is the ratio of the Cost of computers, communications and other services (% of commerical service exports) of Netherlands in 2009 to that in 2011?
Provide a short and direct response. 1.03. What is the ratio of the Cost of computers, communications and other services (% of commerical service exports) of Bangladesh in 2009 to that in 2012?
Your answer should be compact. 1.29. What is the ratio of the Cost of computers, communications and other services (% of commerical service exports) in Kazakhstan in 2009 to that in 2012?
Offer a terse response. 1.14. What is the ratio of the Cost of computers, communications and other services (% of commerical service exports) in Netherlands in 2009 to that in 2012?
Keep it short and to the point. 1.03. What is the ratio of the Cost of computers, communications and other services (% of commerical service exports) in Bangladesh in 2009 to that in 2013?
Offer a terse response. 1.34. What is the ratio of the Cost of computers, communications and other services (% of commerical service exports) in Netherlands in 2009 to that in 2013?
Provide a short and direct response. 1.03. What is the ratio of the Cost of computers, communications and other services (% of commerical service exports) in Bangladesh in 2010 to that in 2011?
Ensure brevity in your answer.  1.1. What is the ratio of the Cost of computers, communications and other services (% of commerical service exports) in Kazakhstan in 2010 to that in 2011?
Your answer should be compact. 0.98. What is the ratio of the Cost of computers, communications and other services (% of commerical service exports) in Netherlands in 2010 to that in 2011?
Make the answer very short. 1.02. What is the ratio of the Cost of computers, communications and other services (% of commerical service exports) in Bangladesh in 2010 to that in 2012?
Keep it short and to the point. 1.32. What is the ratio of the Cost of computers, communications and other services (% of commerical service exports) in Kazakhstan in 2010 to that in 2012?
Provide a succinct answer. 1.09. What is the ratio of the Cost of computers, communications and other services (% of commerical service exports) of Netherlands in 2010 to that in 2012?
Ensure brevity in your answer.  1.02. What is the ratio of the Cost of computers, communications and other services (% of commerical service exports) in Bangladesh in 2010 to that in 2013?
Make the answer very short. 1.37. What is the ratio of the Cost of computers, communications and other services (% of commerical service exports) in Kazakhstan in 2010 to that in 2013?
Make the answer very short. 0.99. What is the ratio of the Cost of computers, communications and other services (% of commerical service exports) of Netherlands in 2010 to that in 2013?
Ensure brevity in your answer.  1.02. What is the ratio of the Cost of computers, communications and other services (% of commerical service exports) of Bangladesh in 2011 to that in 2012?
Your answer should be compact. 1.2. What is the ratio of the Cost of computers, communications and other services (% of commerical service exports) of Kazakhstan in 2011 to that in 2012?
Your response must be concise. 1.1. What is the ratio of the Cost of computers, communications and other services (% of commerical service exports) of Netherlands in 2011 to that in 2012?
Your answer should be very brief. 0.99. What is the ratio of the Cost of computers, communications and other services (% of commerical service exports) in Bangladesh in 2011 to that in 2013?
Make the answer very short. 1.24. What is the ratio of the Cost of computers, communications and other services (% of commerical service exports) in Kazakhstan in 2011 to that in 2013?
Offer a very short reply. 1. What is the ratio of the Cost of computers, communications and other services (% of commerical service exports) of Bangladesh in 2012 to that in 2013?
Provide a short and direct response. 1.03. What is the ratio of the Cost of computers, communications and other services (% of commerical service exports) in Kazakhstan in 2012 to that in 2013?
Offer a terse response. 0.91. What is the difference between the highest and the second highest Cost of computers, communications and other services (% of commerical service exports) in Bangladesh?
Your answer should be compact. 0.86. What is the difference between the highest and the second highest Cost of computers, communications and other services (% of commerical service exports) of Kazakhstan?
Offer a very short reply. 0.33. What is the difference between the highest and the second highest Cost of computers, communications and other services (% of commerical service exports) in Netherlands?
Give a very brief answer. 0.44. What is the difference between the highest and the lowest Cost of computers, communications and other services (% of commerical service exports) of Bangladesh?
Ensure brevity in your answer.  22.41. What is the difference between the highest and the lowest Cost of computers, communications and other services (% of commerical service exports) of Kazakhstan?
Your response must be concise. 3.89. What is the difference between the highest and the lowest Cost of computers, communications and other services (% of commerical service exports) of Netherlands?
Offer a terse response. 3.43. 